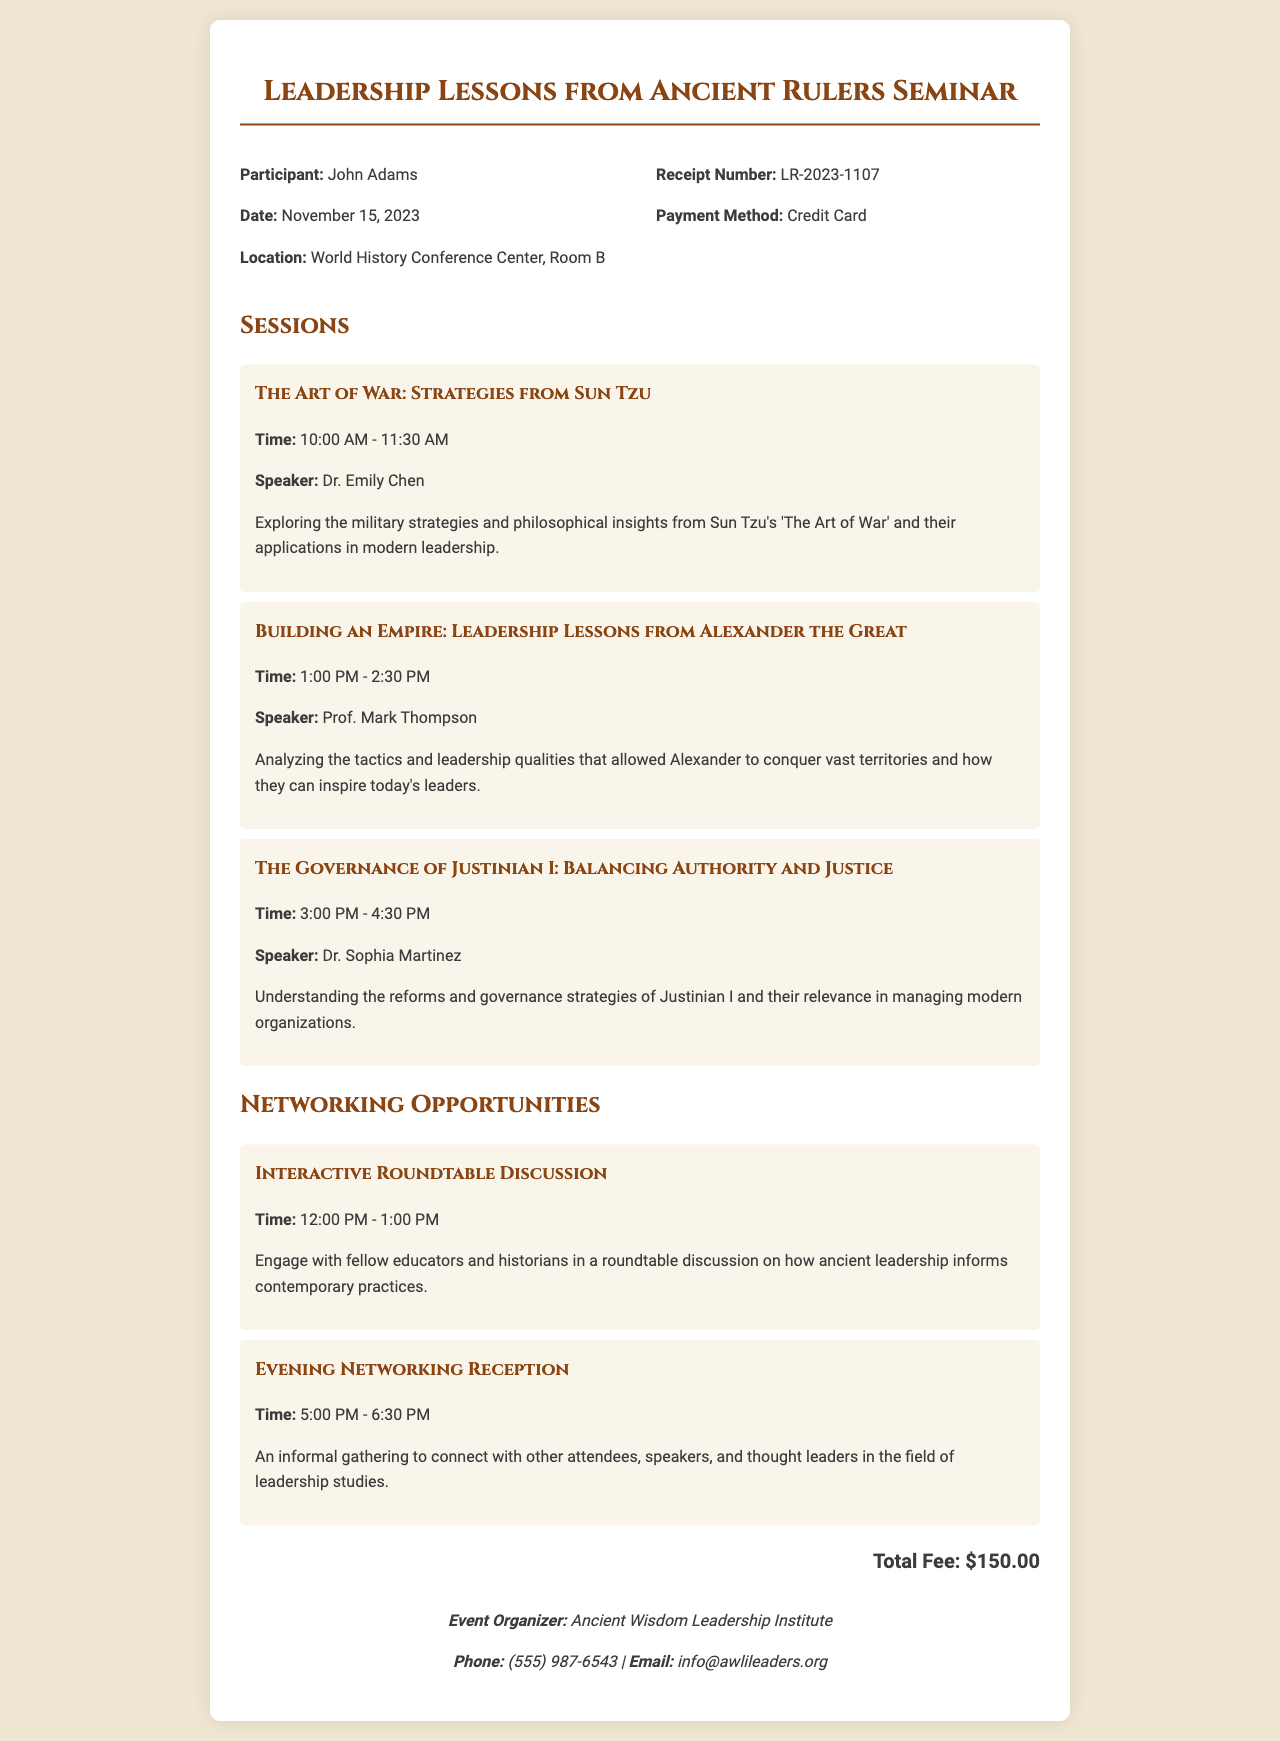What is the date of the seminar? The date of the seminar is mentioned in the receipt details section, which is November 15, 2023.
Answer: November 15, 2023 Who is the speaker for "The Art of War: Strategies from Sun Tzu"? The speaker for this session is provided in the session details, specifically Dr. Emily Chen.
Answer: Dr. Emily Chen What is the total fee for the seminar? The total fee is clearly stated in the document as $150.00.
Answer: $150.00 What time does the Evening Networking Reception start? The start time for this networking opportunity is given, which is 5:00 PM.
Answer: 5:00 PM What session follows "Building an Empire: Leadership Lessons from Alexander the Great"? The document lists the sessions in order, and the next session is "The Governance of Justinian I: Balancing Authority and Justice".
Answer: The Governance of Justinian I: Balancing Authority and Justice How many sessions are listed in the document? The number of sessions can be counted from the sessions section, which contains three sessions.
Answer: Three sessions What organization is responsible for the event? The event organizer's name is provided at the bottom of the document, which is Ancient Wisdom Leadership Institute.
Answer: Ancient Wisdom Leadership Institute What is the time duration of the Interactive Roundtable Discussion? The time for this opportunity is described in the document, which is 12:00 PM - 1:00 PM, making it one hour long.
Answer: 12:00 PM - 1:00 PM 